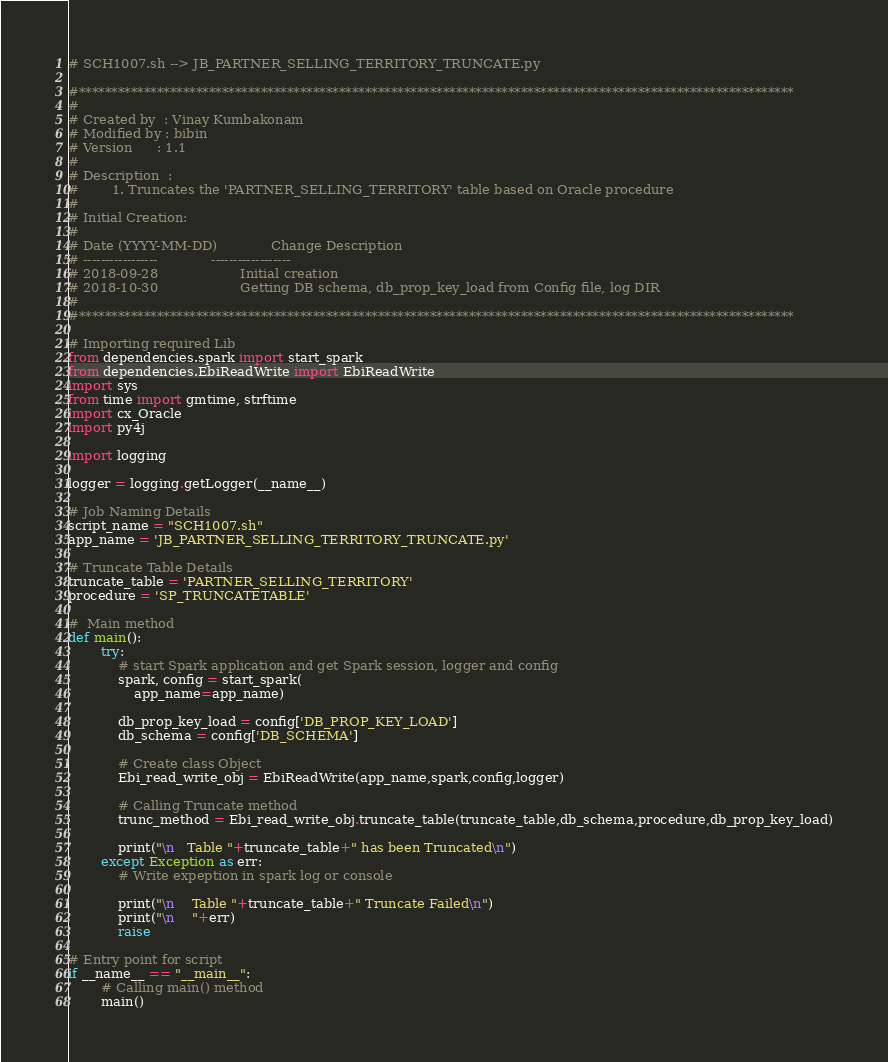<code> <loc_0><loc_0><loc_500><loc_500><_Python_># SCH1007.sh --> JB_PARTNER_SELLING_TERRITORY_TRUNCATE.py

#**************************************************************************************************************
#
# Created by  : Vinay Kumbakonam
# Modified by : bibin
# Version      : 1.1
#
# Description  :
#        1. Truncates the 'PARTNER_SELLING_TERRITORY' table based on Oracle procedure
#
# Initial Creation:
#
# Date (YYYY-MM-DD)             Change Description
# -----------------             ------------------
# 2018-09-28                    Initial creation
# 2018-10-30                    Getting DB schema, db_prop_key_load from Config file, log DIR
#
#**************************************************************************************************************

# Importing required Lib
from dependencies.spark import start_spark
from dependencies.EbiReadWrite import EbiReadWrite
import sys
from time import gmtime, strftime
import cx_Oracle
import py4j

import logging

logger = logging.getLogger(__name__)

# Job Naming Details
script_name = "SCH1007.sh"
app_name = 'JB_PARTNER_SELLING_TERRITORY_TRUNCATE.py'

# Truncate Table Details
truncate_table = 'PARTNER_SELLING_TERRITORY'
procedure = 'SP_TRUNCATETABLE'

#  Main method
def main():
        try:
            # start Spark application and get Spark session, logger and config
            spark, config = start_spark(
                app_name=app_name)

            db_prop_key_load = config['DB_PROP_KEY_LOAD']
            db_schema = config['DB_SCHEMA']

            # Create class Object
            Ebi_read_write_obj = EbiReadWrite(app_name,spark,config,logger)

            # Calling Truncate method
            trunc_method = Ebi_read_write_obj.truncate_table(truncate_table,db_schema,procedure,db_prop_key_load)

            print("\n   Table "+truncate_table+" has been Truncated\n")
        except Exception as err:
            # Write expeption in spark log or console
            
            print("\n	Table "+truncate_table+" Truncate Failed\n")
            print("\n	"+err)
            raise

# Entry point for script
if __name__ == "__main__":
        # Calling main() method
        main()

</code> 